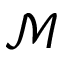Convert formula to latex. <formula><loc_0><loc_0><loc_500><loc_500>\mathcal { M }</formula> 